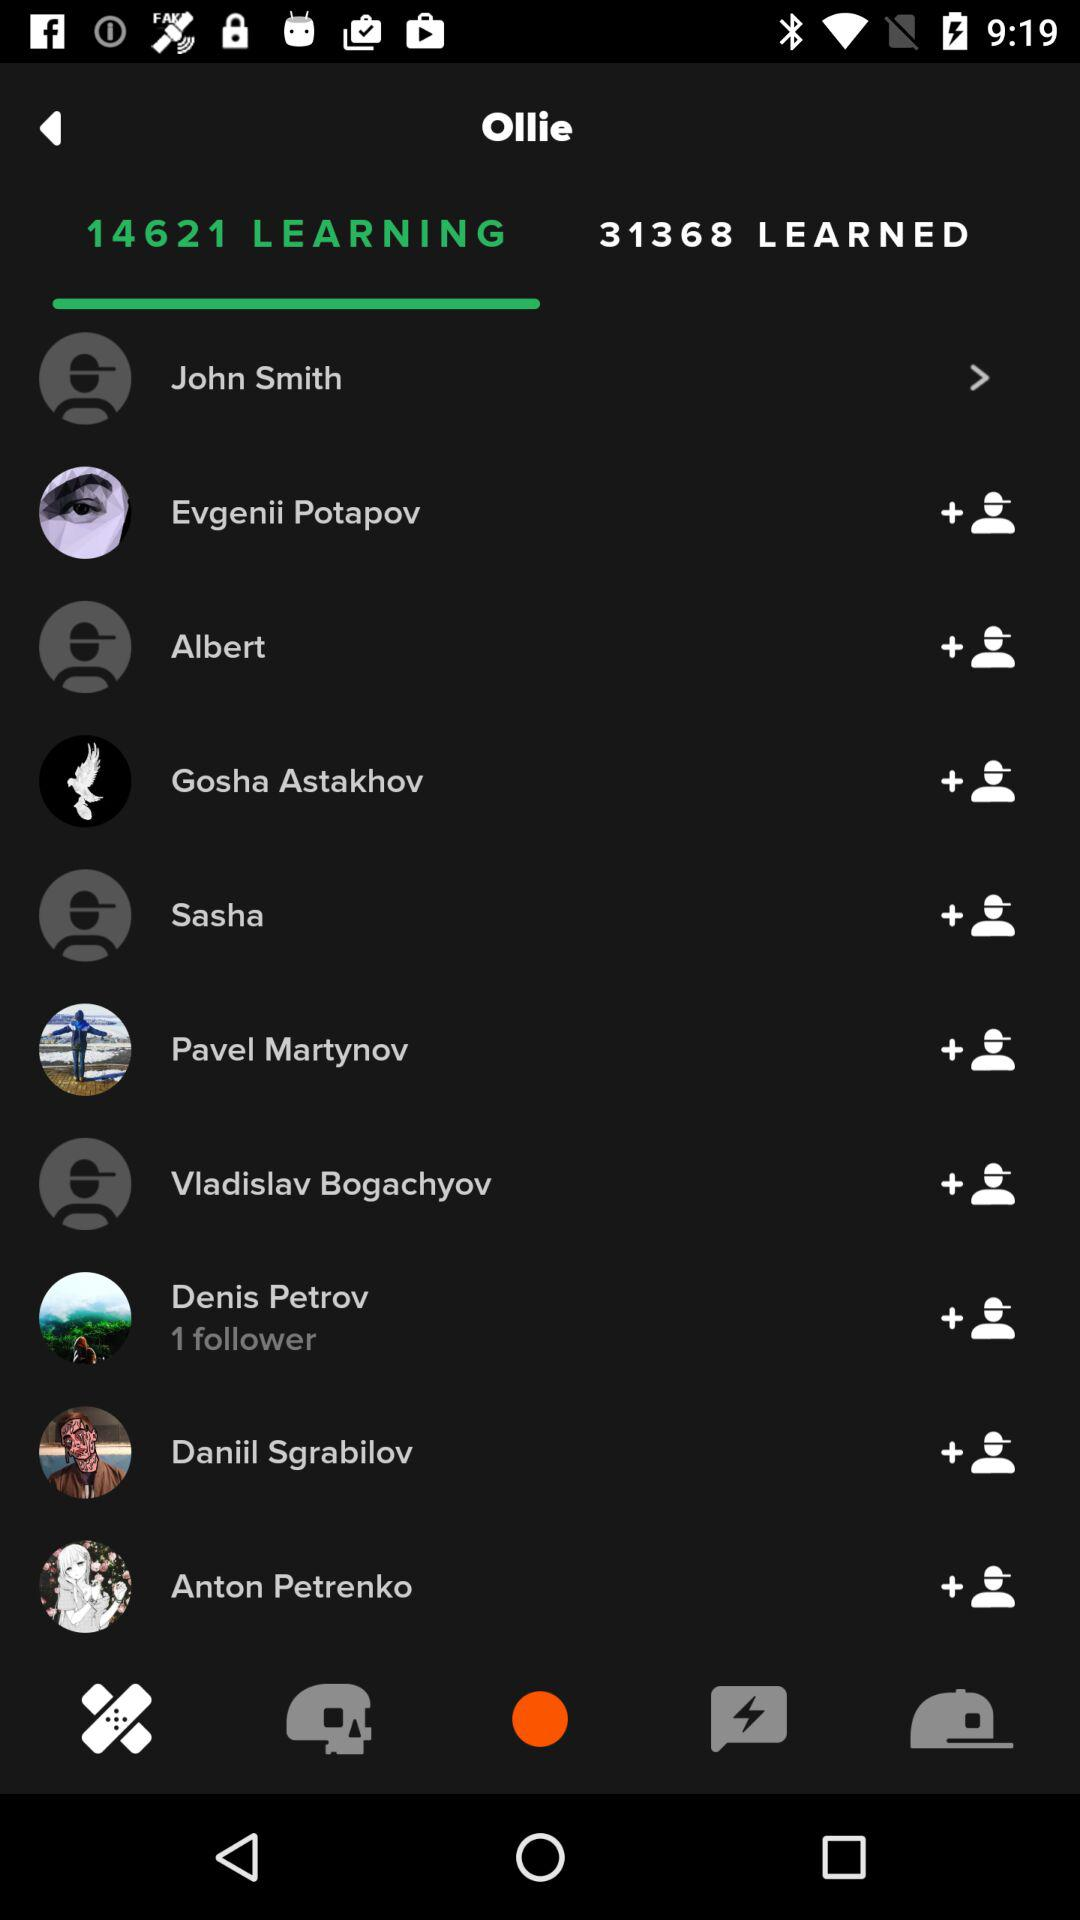How many followers does Denis Petrov have? Denis Petrov has 1 follower. 